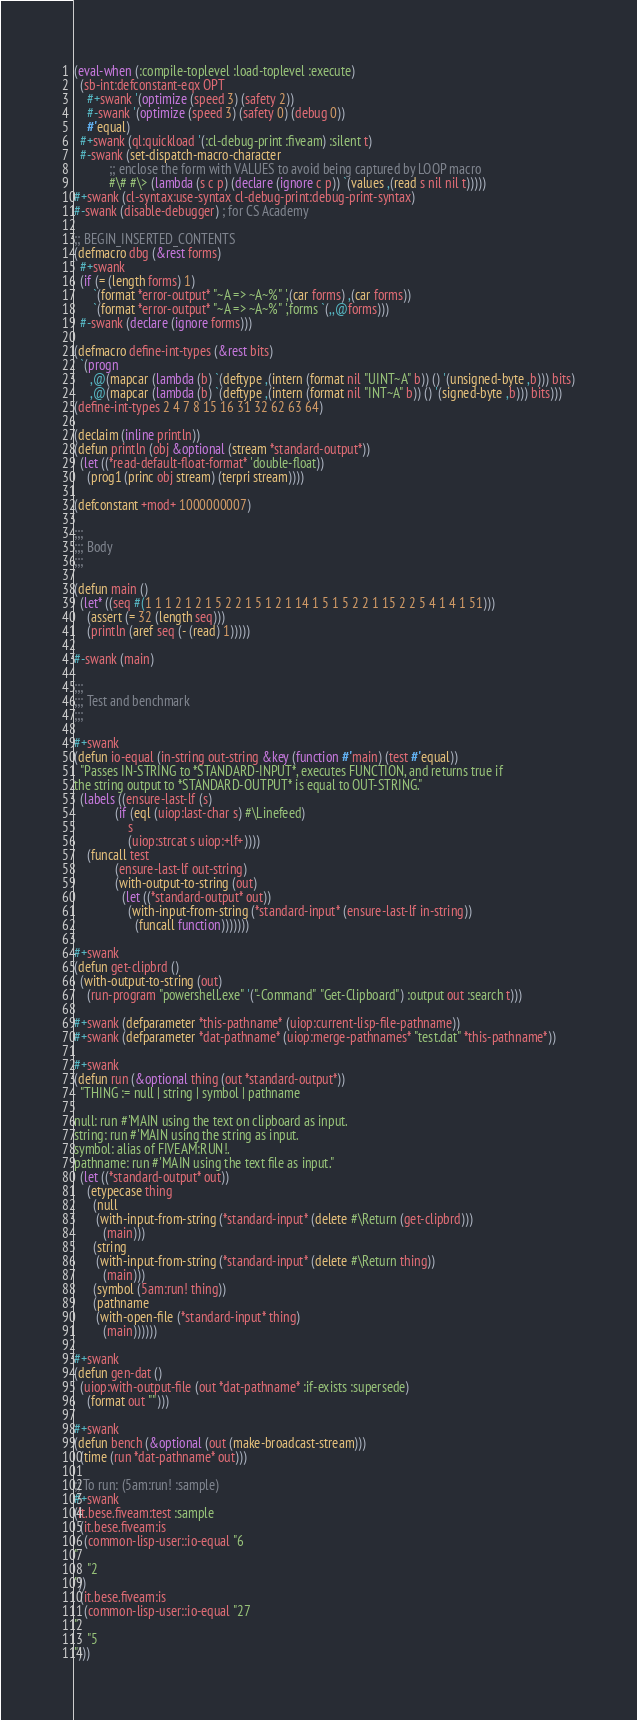Convert code to text. <code><loc_0><loc_0><loc_500><loc_500><_Lisp_>(eval-when (:compile-toplevel :load-toplevel :execute)
  (sb-int:defconstant-eqx OPT
    #+swank '(optimize (speed 3) (safety 2))
    #-swank '(optimize (speed 3) (safety 0) (debug 0))
    #'equal)
  #+swank (ql:quickload '(:cl-debug-print :fiveam) :silent t)
  #-swank (set-dispatch-macro-character
           ;; enclose the form with VALUES to avoid being captured by LOOP macro
           #\# #\> (lambda (s c p) (declare (ignore c p)) `(values ,(read s nil nil t)))))
#+swank (cl-syntax:use-syntax cl-debug-print:debug-print-syntax)
#-swank (disable-debugger) ; for CS Academy

;; BEGIN_INSERTED_CONTENTS
(defmacro dbg (&rest forms)
  #+swank
  (if (= (length forms) 1)
      `(format *error-output* "~A => ~A~%" ',(car forms) ,(car forms))
      `(format *error-output* "~A => ~A~%" ',forms `(,,@forms)))
  #-swank (declare (ignore forms)))

(defmacro define-int-types (&rest bits)
  `(progn
     ,@(mapcar (lambda (b) `(deftype ,(intern (format nil "UINT~A" b)) () '(unsigned-byte ,b))) bits)
     ,@(mapcar (lambda (b) `(deftype ,(intern (format nil "INT~A" b)) () '(signed-byte ,b))) bits)))
(define-int-types 2 4 7 8 15 16 31 32 62 63 64)

(declaim (inline println))
(defun println (obj &optional (stream *standard-output*))
  (let ((*read-default-float-format* 'double-float))
    (prog1 (princ obj stream) (terpri stream))))

(defconstant +mod+ 1000000007)

;;;
;;; Body
;;;

(defun main ()
  (let* ((seq #(1 1 1 2 1 2 1 5 2 2 1 5 1 2 1 14 1 5 1 5 2 2 1 15 2 2 5 4 1 4 1 51)))
    (assert (= 32 (length seq)))
    (println (aref seq (- (read) 1)))))

#-swank (main)

;;;
;;; Test and benchmark
;;;

#+swank
(defun io-equal (in-string out-string &key (function #'main) (test #'equal))
  "Passes IN-STRING to *STANDARD-INPUT*, executes FUNCTION, and returns true if
the string output to *STANDARD-OUTPUT* is equal to OUT-STRING."
  (labels ((ensure-last-lf (s)
             (if (eql (uiop:last-char s) #\Linefeed)
                 s
                 (uiop:strcat s uiop:+lf+))))
    (funcall test
             (ensure-last-lf out-string)
             (with-output-to-string (out)
               (let ((*standard-output* out))
                 (with-input-from-string (*standard-input* (ensure-last-lf in-string))
                   (funcall function)))))))

#+swank
(defun get-clipbrd ()
  (with-output-to-string (out)
    (run-program "powershell.exe" '("-Command" "Get-Clipboard") :output out :search t)))

#+swank (defparameter *this-pathname* (uiop:current-lisp-file-pathname))
#+swank (defparameter *dat-pathname* (uiop:merge-pathnames* "test.dat" *this-pathname*))

#+swank
(defun run (&optional thing (out *standard-output*))
  "THING := null | string | symbol | pathname

null: run #'MAIN using the text on clipboard as input.
string: run #'MAIN using the string as input.
symbol: alias of FIVEAM:RUN!.
pathname: run #'MAIN using the text file as input."
  (let ((*standard-output* out))
    (etypecase thing
      (null
       (with-input-from-string (*standard-input* (delete #\Return (get-clipbrd)))
         (main)))
      (string
       (with-input-from-string (*standard-input* (delete #\Return thing))
         (main)))
      (symbol (5am:run! thing))
      (pathname
       (with-open-file (*standard-input* thing)
         (main))))))

#+swank
(defun gen-dat ()
  (uiop:with-output-file (out *dat-pathname* :if-exists :supersede)
    (format out "")))

#+swank
(defun bench (&optional (out (make-broadcast-stream)))
  (time (run *dat-pathname* out)))

;; To run: (5am:run! :sample)
#+swank
(it.bese.fiveam:test :sample
  (it.bese.fiveam:is
   (common-lisp-user::io-equal "6
"
    "2
"))
  (it.bese.fiveam:is
   (common-lisp-user::io-equal "27
"
    "5
")))
</code> 